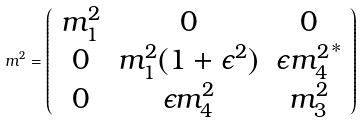Convert formula to latex. <formula><loc_0><loc_0><loc_500><loc_500>m ^ { 2 } = \left ( \begin{array} { c c c } m _ { 1 } ^ { 2 } & 0 & 0 \\ 0 & m _ { 1 } ^ { 2 } ( 1 + \epsilon ^ { 2 } ) & \epsilon { m _ { 4 } ^ { 2 } } ^ { * } \\ 0 & \epsilon m _ { 4 } ^ { 2 } & m _ { 3 } ^ { 2 } \end{array} \right )</formula> 